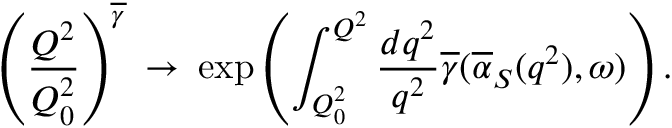Convert formula to latex. <formula><loc_0><loc_0><loc_500><loc_500>\left ( \frac { Q ^ { 2 } } { Q _ { 0 } ^ { 2 } } \right ) ^ { \overline { \gamma } } \, \rightarrow \, \exp \left ( \int _ { Q _ { 0 } ^ { 2 } } ^ { Q ^ { 2 } } \frac { d q ^ { 2 } } { q ^ { 2 } } \overline { \gamma } ( \overline { \alpha } _ { S } ( q ^ { 2 } ) , \omega ) \right ) .</formula> 